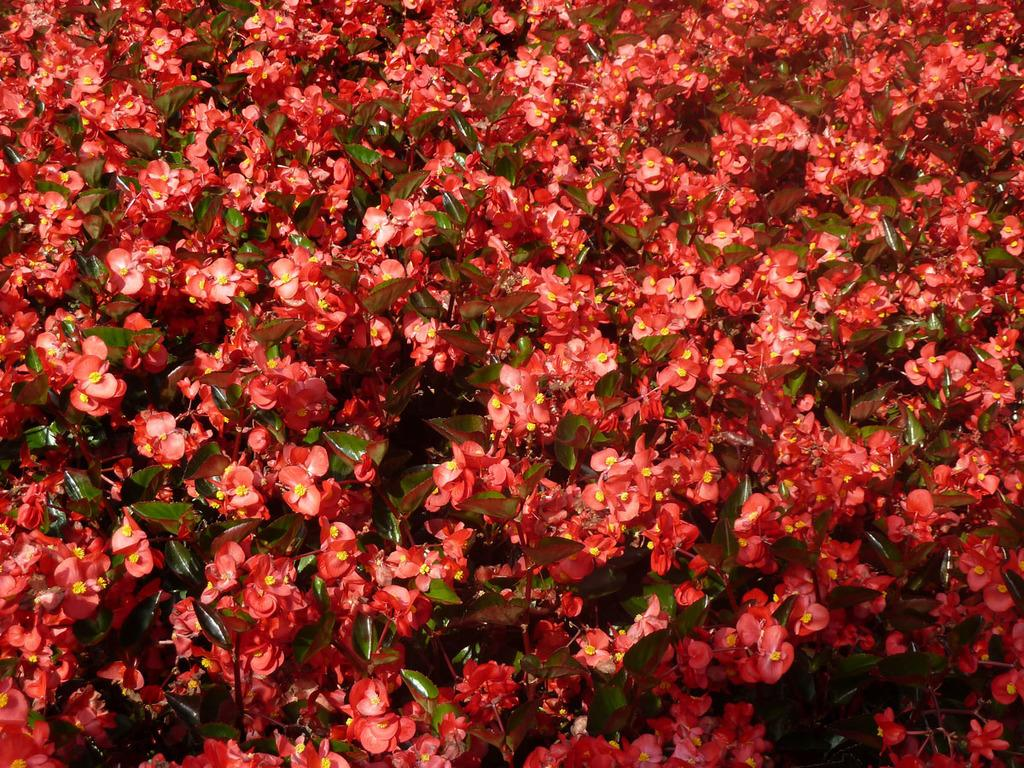What type of plants can be seen in the image? There are flowers in the image. What part of the plants can also be seen in the image? There are leaves in the image. What type of wall can be seen in the image? There is no wall present in the image; it features flowers and leaves. Can you see any faces or arms in the image? There are no faces or arms visible in the image; it only contains flowers and leaves. 